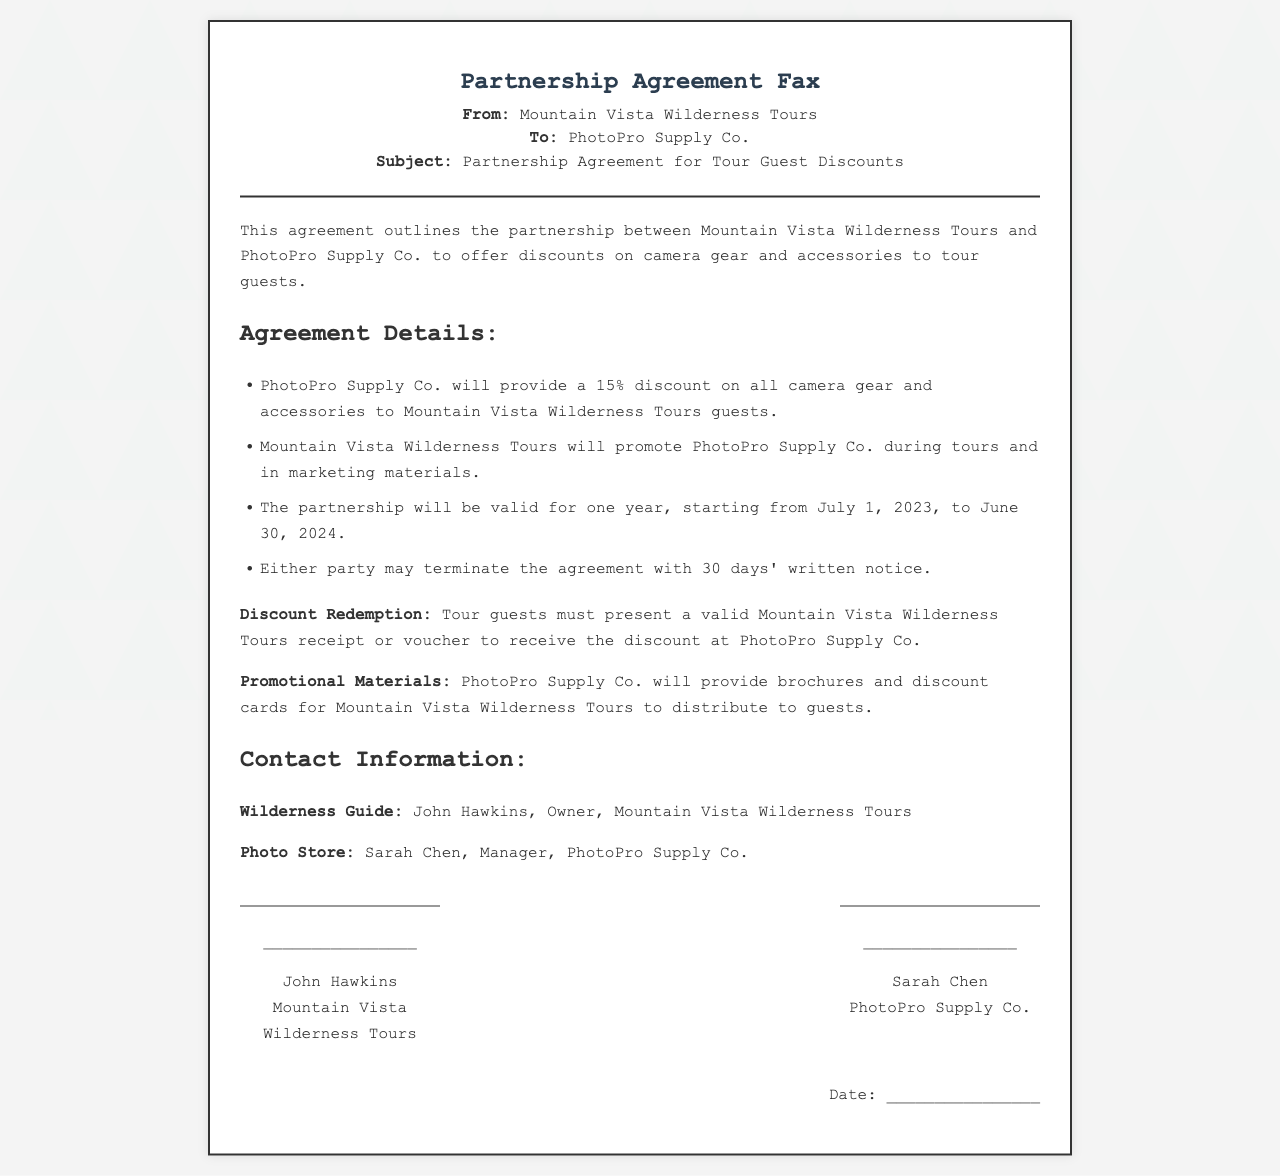What is the discount percentage offered? The document states that PhotoPro Supply Co. will provide a 15% discount on all camera gear and accessories.
Answer: 15% Who is the owner of Mountain Vista Wilderness Tours? The document identifies John Hawkins as the owner of Mountain Vista Wilderness Tours.
Answer: John Hawkins What is the duration of the partnership agreement? The partnership agreement is valid for one year, starting from July 1, 2023, to June 30, 2024.
Answer: One year Who must present a receipt to receive the discount? According to the agreement, tour guests must present a valid Mountain Vista Wilderness Tours receipt or voucher.
Answer: Tour guests How many days' notice is required to terminate the agreement? The document specifies that either party may terminate the agreement with 30 days' written notice.
Answer: 30 days What promotional materials will PhotoPro Supply Co. provide? The agreement mentions that PhotoPro Supply Co. will provide brochures and discount cards for Mountain Vista Wilderness Tours.
Answer: Brochures and discount cards What is the full name of the manager at PhotoPro Supply Co.? The document lists Sarah Chen as the manager of PhotoPro Supply Co.
Answer: Sarah Chen In which month does the partnership agreement start? The partnership agreement starts in July.
Answer: July 